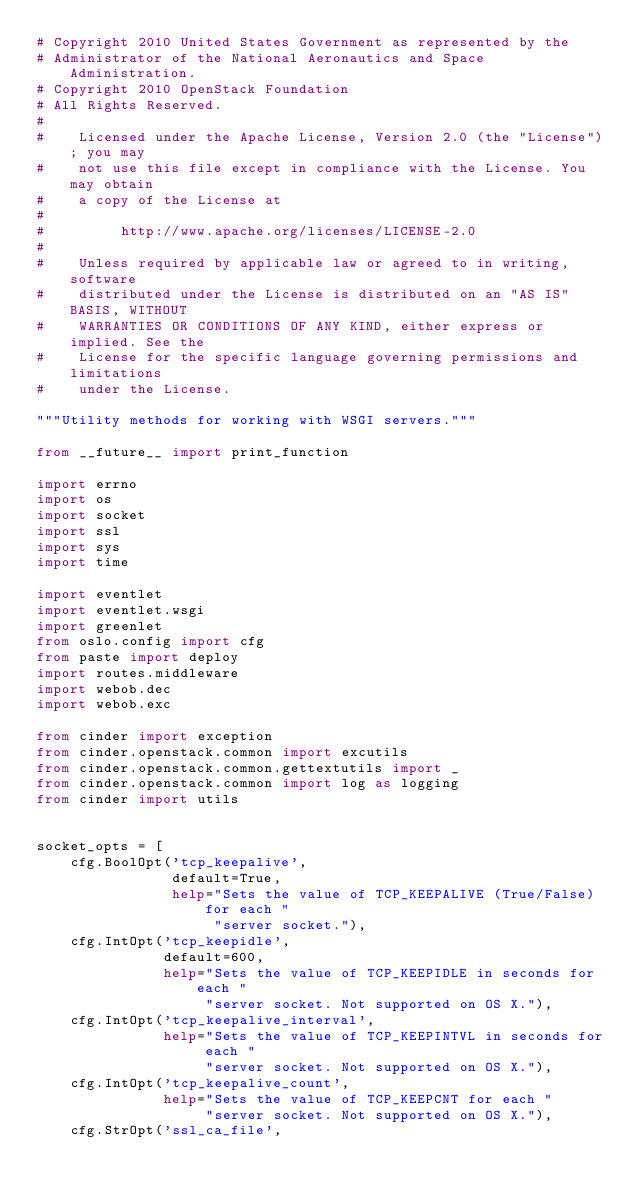<code> <loc_0><loc_0><loc_500><loc_500><_Python_># Copyright 2010 United States Government as represented by the
# Administrator of the National Aeronautics and Space Administration.
# Copyright 2010 OpenStack Foundation
# All Rights Reserved.
#
#    Licensed under the Apache License, Version 2.0 (the "License"); you may
#    not use this file except in compliance with the License. You may obtain
#    a copy of the License at
#
#         http://www.apache.org/licenses/LICENSE-2.0
#
#    Unless required by applicable law or agreed to in writing, software
#    distributed under the License is distributed on an "AS IS" BASIS, WITHOUT
#    WARRANTIES OR CONDITIONS OF ANY KIND, either express or implied. See the
#    License for the specific language governing permissions and limitations
#    under the License.

"""Utility methods for working with WSGI servers."""

from __future__ import print_function

import errno
import os
import socket
import ssl
import sys
import time

import eventlet
import eventlet.wsgi
import greenlet
from oslo.config import cfg
from paste import deploy
import routes.middleware
import webob.dec
import webob.exc

from cinder import exception
from cinder.openstack.common import excutils
from cinder.openstack.common.gettextutils import _
from cinder.openstack.common import log as logging
from cinder import utils


socket_opts = [
    cfg.BoolOpt('tcp_keepalive',
                default=True,
                help="Sets the value of TCP_KEEPALIVE (True/False) for each "
                     "server socket."),
    cfg.IntOpt('tcp_keepidle',
               default=600,
               help="Sets the value of TCP_KEEPIDLE in seconds for each "
                    "server socket. Not supported on OS X."),
    cfg.IntOpt('tcp_keepalive_interval',
               help="Sets the value of TCP_KEEPINTVL in seconds for each "
                    "server socket. Not supported on OS X."),
    cfg.IntOpt('tcp_keepalive_count',
               help="Sets the value of TCP_KEEPCNT for each "
                    "server socket. Not supported on OS X."),
    cfg.StrOpt('ssl_ca_file',</code> 